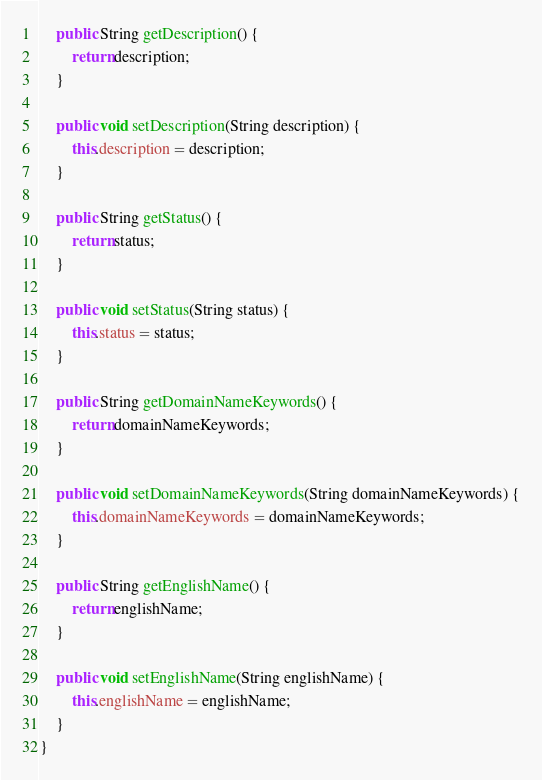<code> <loc_0><loc_0><loc_500><loc_500><_Java_>    public String getDescription() {
        return description;
    }

    public void setDescription(String description) {
        this.description = description;
    }

    public String getStatus() {
        return status;
    }

    public void setStatus(String status) {
        this.status = status;
    }

    public String getDomainNameKeywords() {
        return domainNameKeywords;
    }

    public void setDomainNameKeywords(String domainNameKeywords) {
        this.domainNameKeywords = domainNameKeywords;
    }

    public String getEnglishName() {
        return englishName;
    }

    public void setEnglishName(String englishName) {
        this.englishName = englishName;
    }
}
</code> 